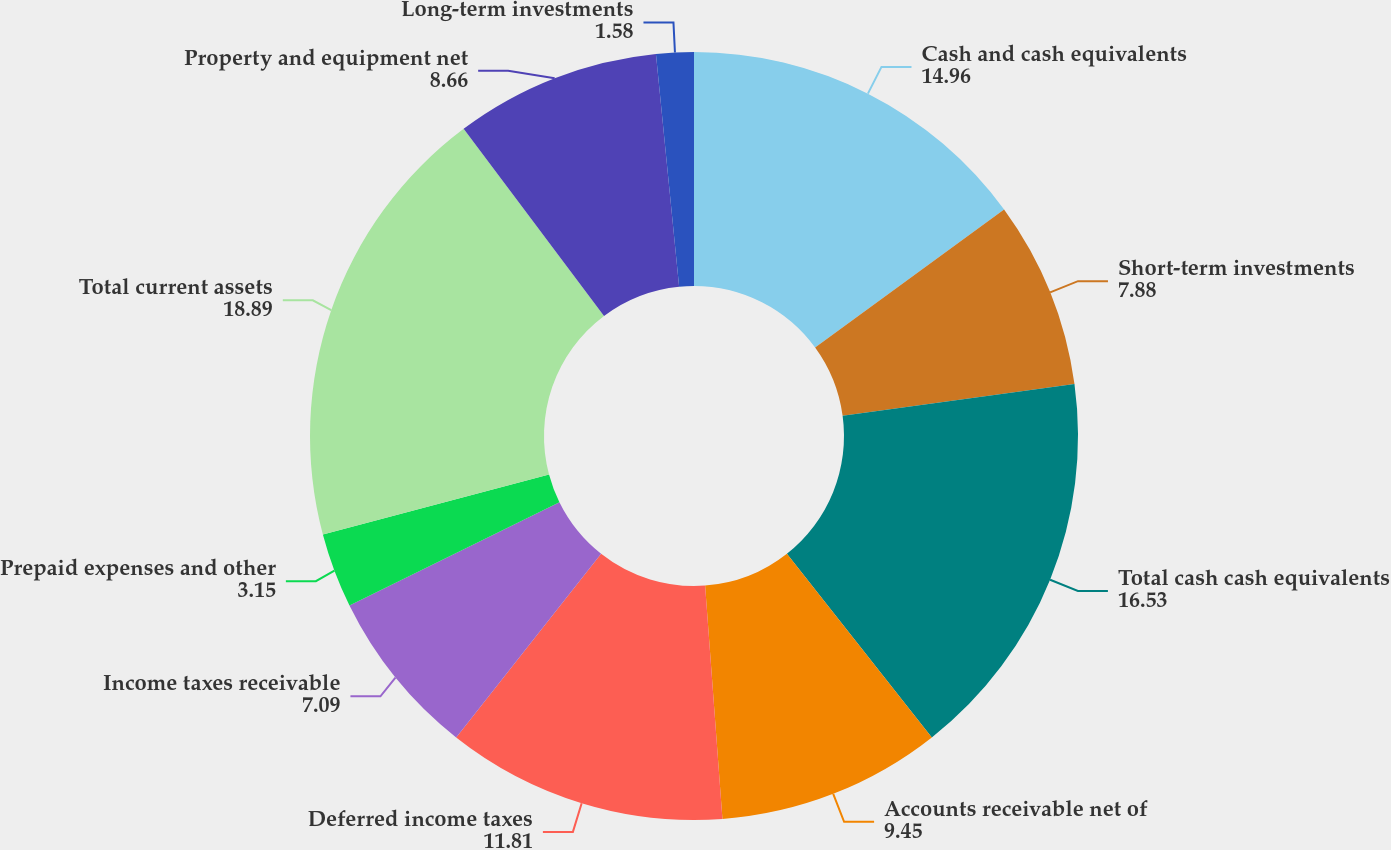Convert chart to OTSL. <chart><loc_0><loc_0><loc_500><loc_500><pie_chart><fcel>Cash and cash equivalents<fcel>Short-term investments<fcel>Total cash cash equivalents<fcel>Accounts receivable net of<fcel>Deferred income taxes<fcel>Income taxes receivable<fcel>Prepaid expenses and other<fcel>Total current assets<fcel>Property and equipment net<fcel>Long-term investments<nl><fcel>14.96%<fcel>7.88%<fcel>16.53%<fcel>9.45%<fcel>11.81%<fcel>7.09%<fcel>3.15%<fcel>18.89%<fcel>8.66%<fcel>1.58%<nl></chart> 